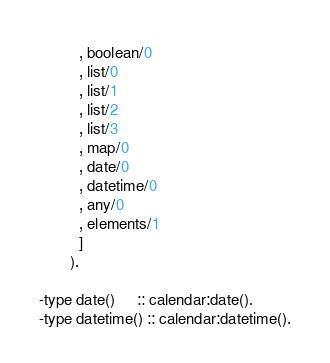<code> <loc_0><loc_0><loc_500><loc_500><_Erlang_>         , boolean/0
         , list/0
         , list/1
         , list/2
         , list/3
         , map/0
         , date/0
         , datetime/0
         , any/0
         , elements/1
         ]
       ).

-type date()     :: calendar:date().
-type datetime() :: calendar:datetime().
</code> 